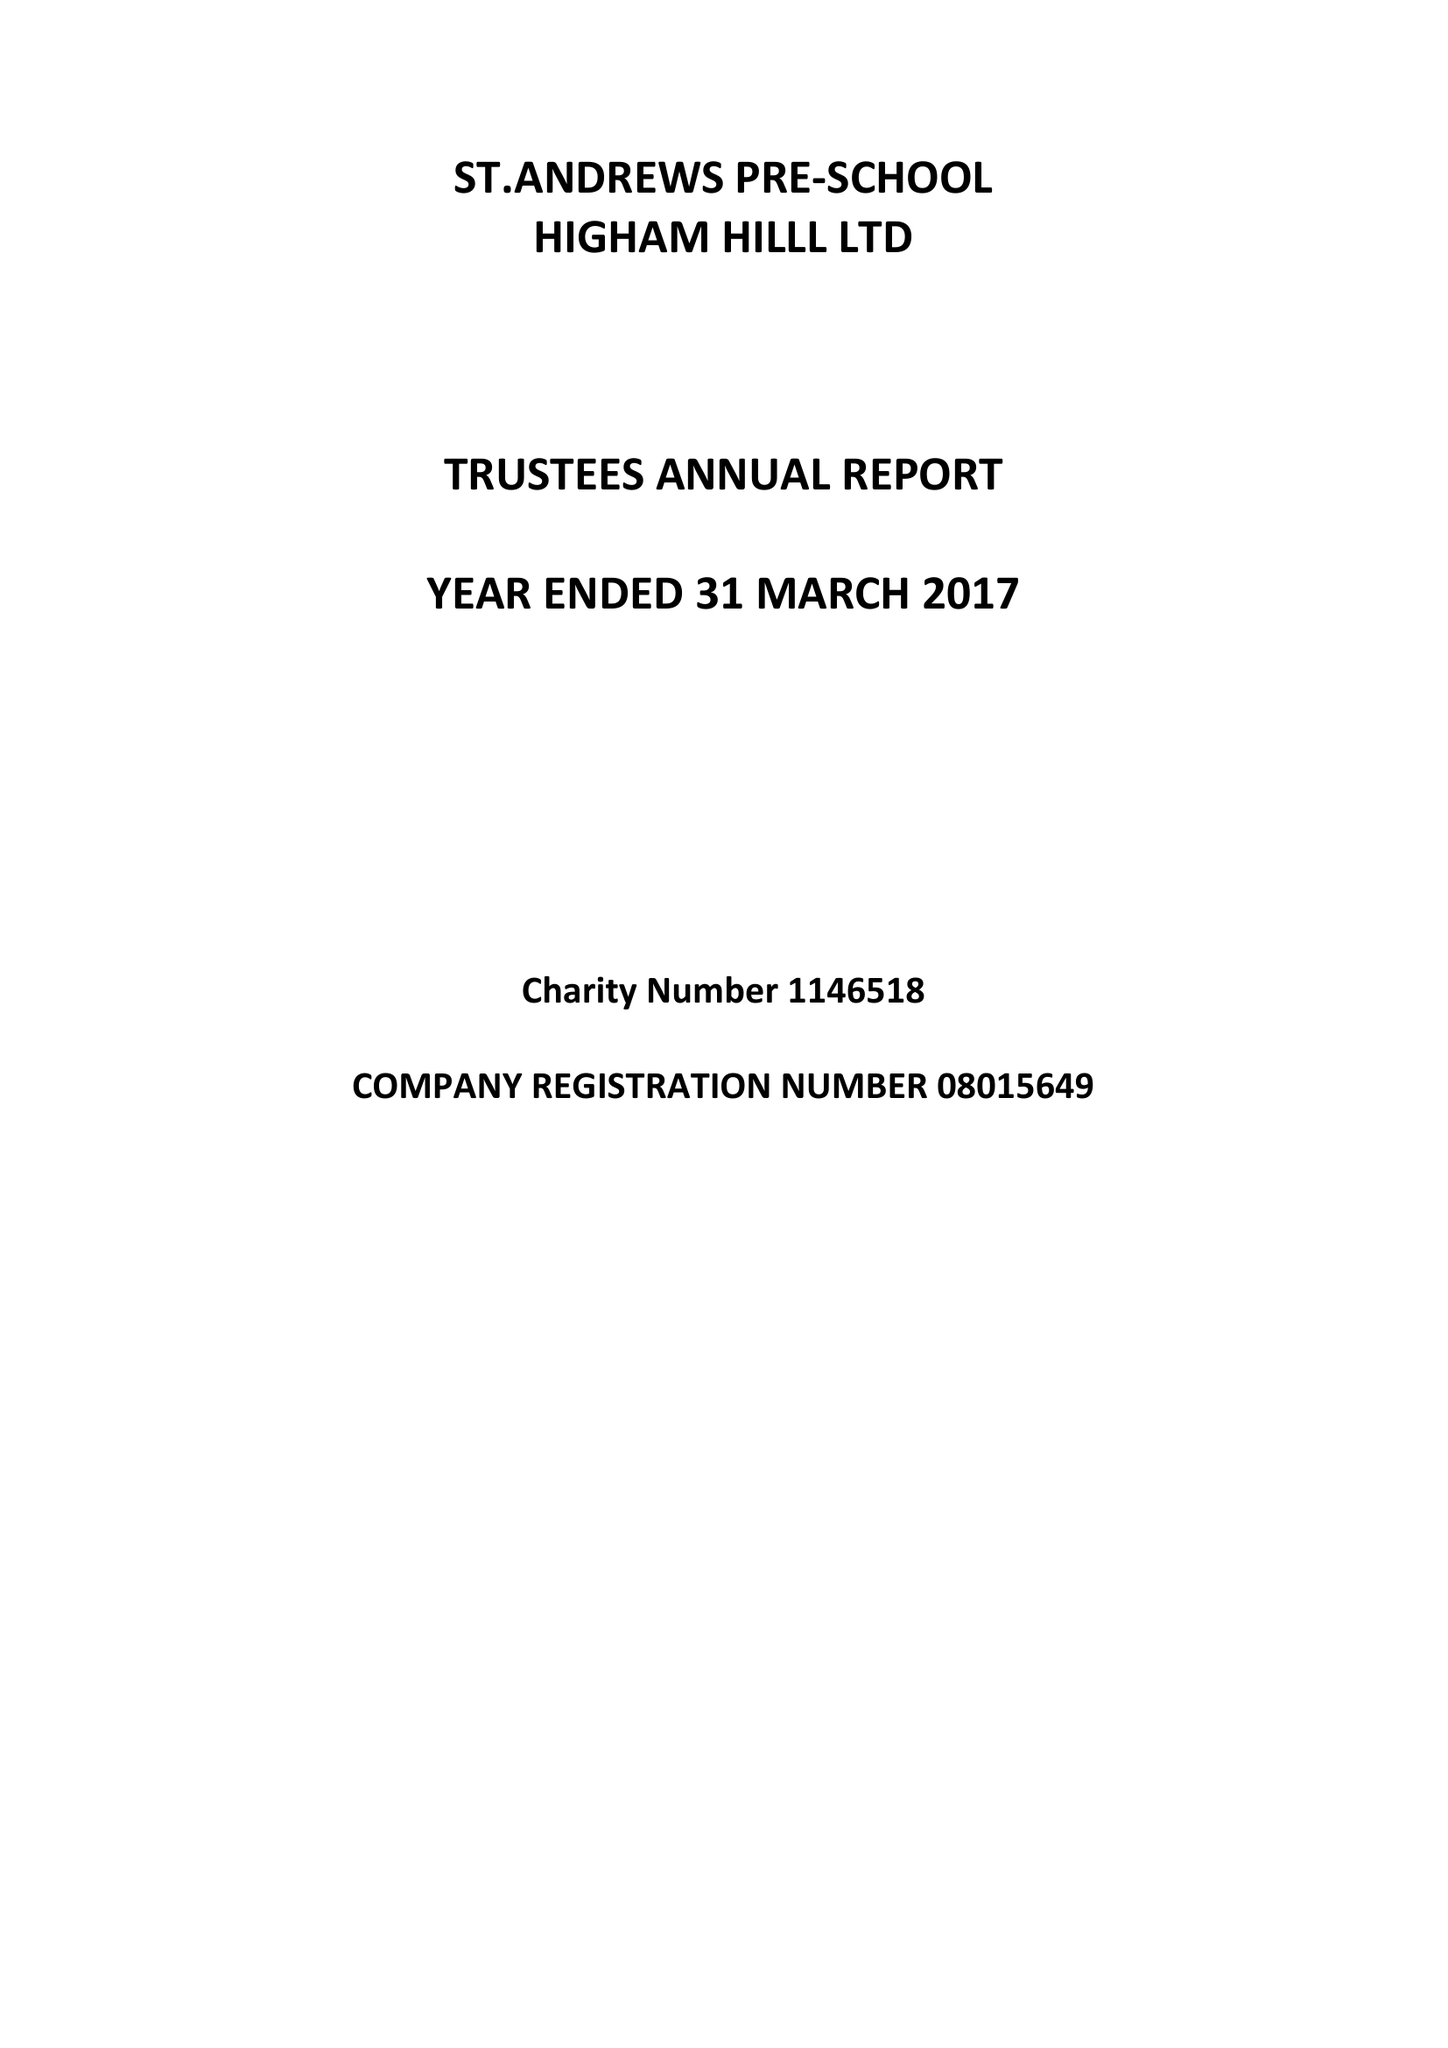What is the value for the address__postcode?
Answer the question using a single word or phrase. E17 6AR 